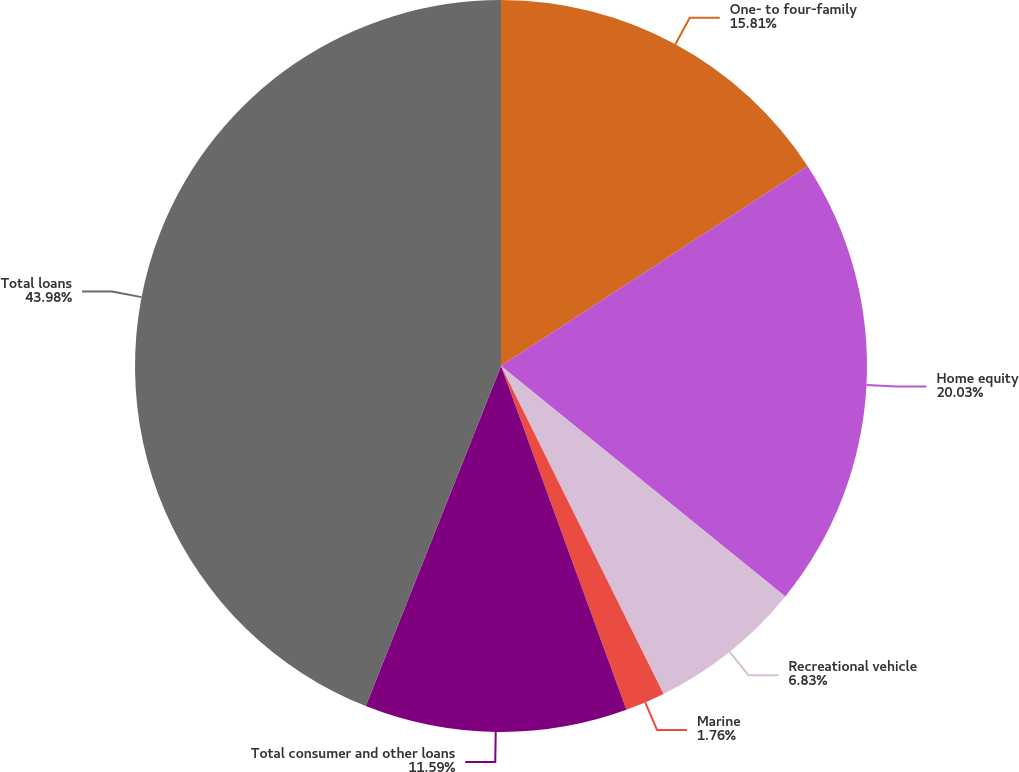<chart> <loc_0><loc_0><loc_500><loc_500><pie_chart><fcel>One- to four-family<fcel>Home equity<fcel>Recreational vehicle<fcel>Marine<fcel>Total consumer and other loans<fcel>Total loans<nl><fcel>15.81%<fcel>20.03%<fcel>6.83%<fcel>1.76%<fcel>11.59%<fcel>43.97%<nl></chart> 